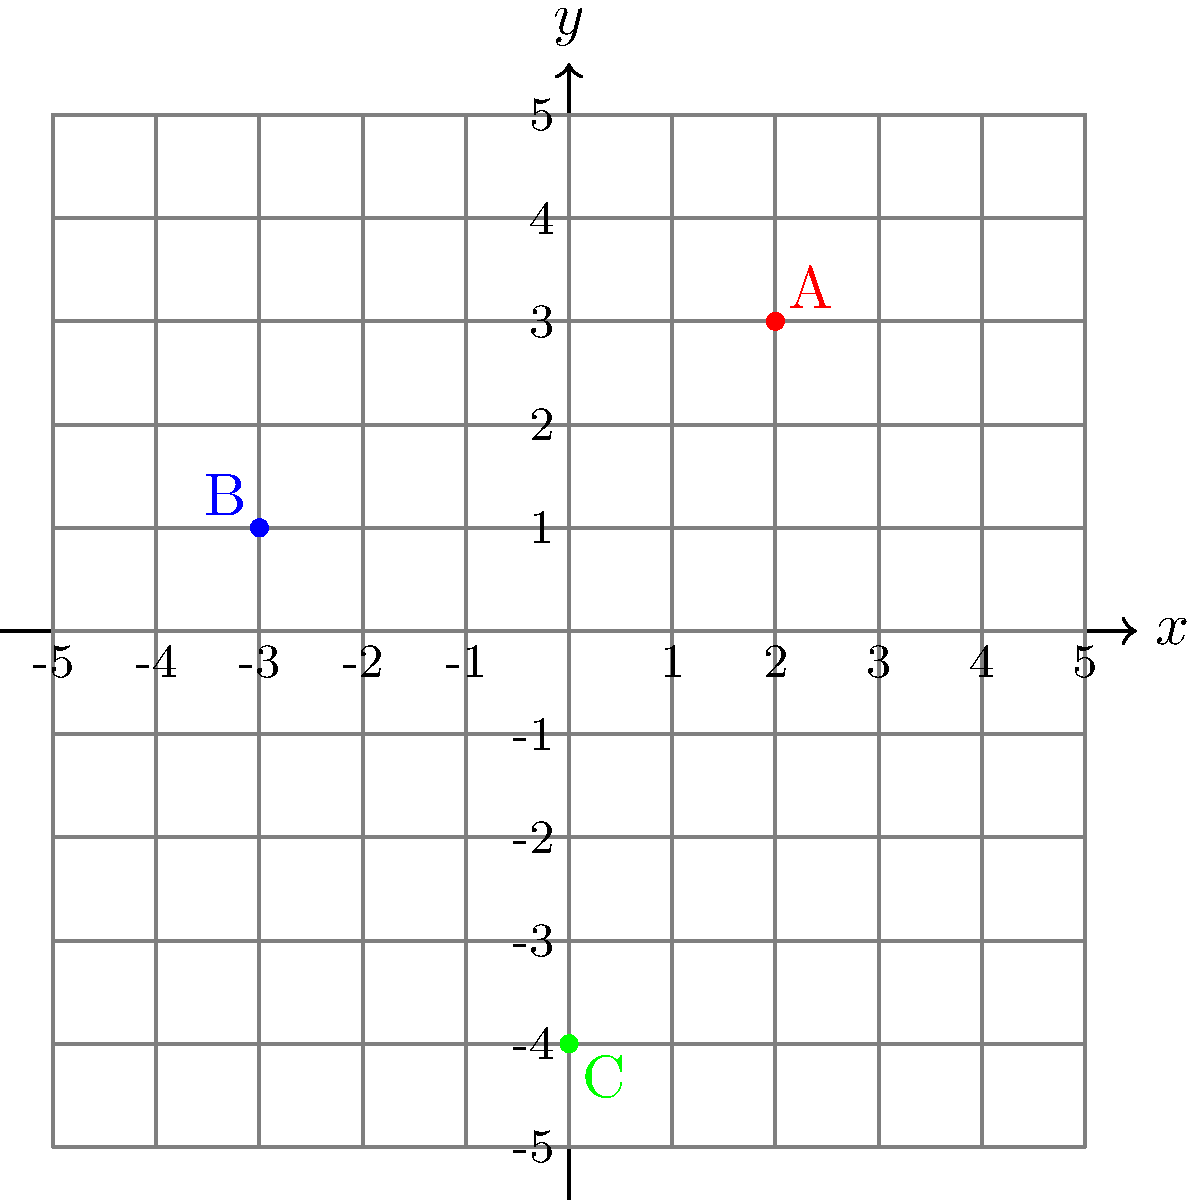Look at the coordinate plane above. Three colored points are marked: A (red), B (blue), and C (green). Which point is located at the coordinates $(2, 3)$? Let's approach this step-by-step:

1. We need to understand how to read coordinates:
   - The first number in a coordinate pair represents the x-coordinate (horizontal position).
   - The second number represents the y-coordinate (vertical position).

2. The question asks about the point at $(2, 3)$. This means:
   - We need to find a point that is 2 units to the right of the y-axis (x = 2)
   - And 3 units up from the x-axis (y = 3)

3. Let's check each point:
   - Point A (red): This point is 2 units to the right and 3 units up. It matches $(2, 3)$.
   - Point B (blue): This point is to the left of the y-axis and only 1 unit up. It doesn't match.
   - Point C (green): This point is on the y-axis and below the x-axis. It doesn't match.

4. Therefore, the point located at $(2, 3)$ is point A, the red point.
Answer: Point A (red) 